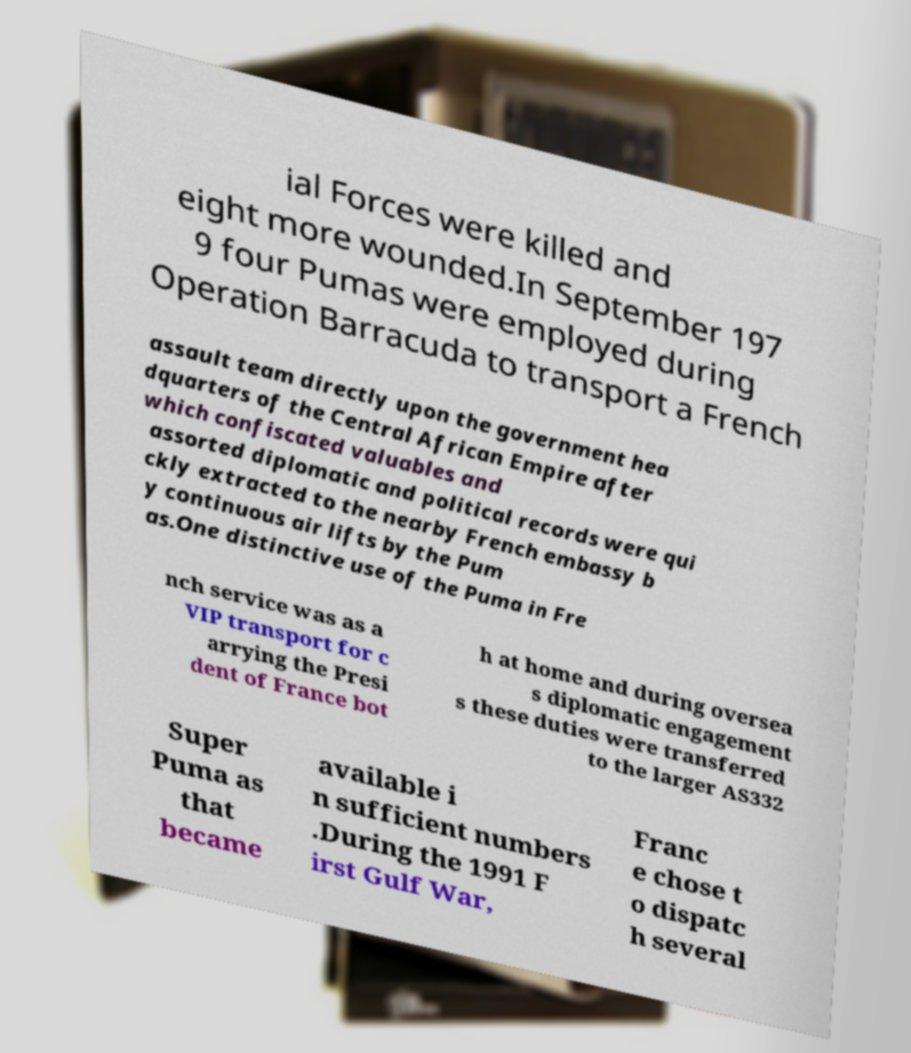What messages or text are displayed in this image? I need them in a readable, typed format. ial Forces were killed and eight more wounded.In September 197 9 four Pumas were employed during Operation Barracuda to transport a French assault team directly upon the government hea dquarters of the Central African Empire after which confiscated valuables and assorted diplomatic and political records were qui ckly extracted to the nearby French embassy b y continuous air lifts by the Pum as.One distinctive use of the Puma in Fre nch service was as a VIP transport for c arrying the Presi dent of France bot h at home and during oversea s diplomatic engagement s these duties were transferred to the larger AS332 Super Puma as that became available i n sufficient numbers .During the 1991 F irst Gulf War, Franc e chose t o dispatc h several 